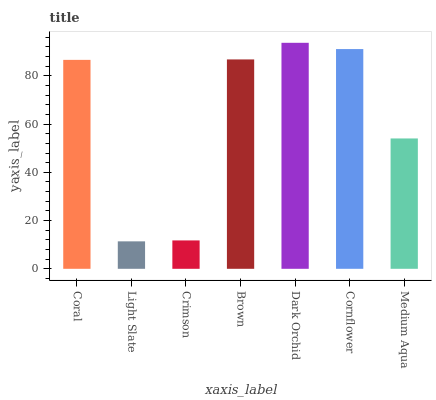Is Light Slate the minimum?
Answer yes or no. Yes. Is Dark Orchid the maximum?
Answer yes or no. Yes. Is Crimson the minimum?
Answer yes or no. No. Is Crimson the maximum?
Answer yes or no. No. Is Crimson greater than Light Slate?
Answer yes or no. Yes. Is Light Slate less than Crimson?
Answer yes or no. Yes. Is Light Slate greater than Crimson?
Answer yes or no. No. Is Crimson less than Light Slate?
Answer yes or no. No. Is Coral the high median?
Answer yes or no. Yes. Is Coral the low median?
Answer yes or no. Yes. Is Brown the high median?
Answer yes or no. No. Is Medium Aqua the low median?
Answer yes or no. No. 